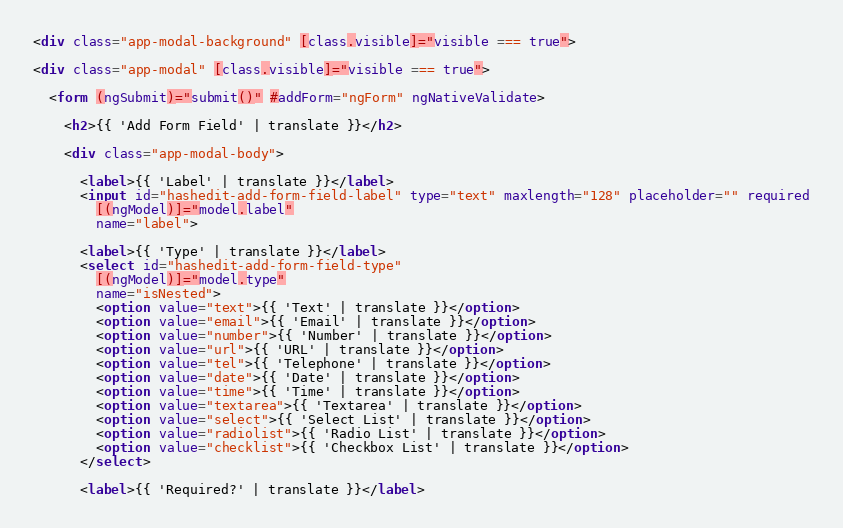<code> <loc_0><loc_0><loc_500><loc_500><_HTML_><div class="app-modal-background" [class.visible]="visible === true">

<div class="app-modal" [class.visible]="visible === true">

  <form (ngSubmit)="submit()" #addForm="ngForm" ngNativeValidate>

    <h2>{{ 'Add Form Field' | translate }}</h2>

    <div class="app-modal-body">

      <label>{{ 'Label' | translate }}</label>
      <input id="hashedit-add-form-field-label" type="text" maxlength="128" placeholder="" required
        [(ngModel)]="model.label"
        name="label">

      <label>{{ 'Type' | translate }}</label>
      <select id="hashedit-add-form-field-type"
        [(ngModel)]="model.type"
        name="isNested">
        <option value="text">{{ 'Text' | translate }}</option>
        <option value="email">{{ 'Email' | translate }}</option>
        <option value="number">{{ 'Number' | translate }}</option>
        <option value="url">{{ 'URL' | translate }}</option>
        <option value="tel">{{ 'Telephone' | translate }}</option>
        <option value="date">{{ 'Date' | translate }}</option>
        <option value="time">{{ 'Time' | translate }}</option>
        <option value="textarea">{{ 'Textarea' | translate }}</option>
        <option value="select">{{ 'Select List' | translate }}</option>
        <option value="radiolist">{{ 'Radio List' | translate }}</option>
        <option value="checklist">{{ 'Checkbox List' | translate }}</option>
      </select>

      <label>{{ 'Required?' | translate }}</label></code> 